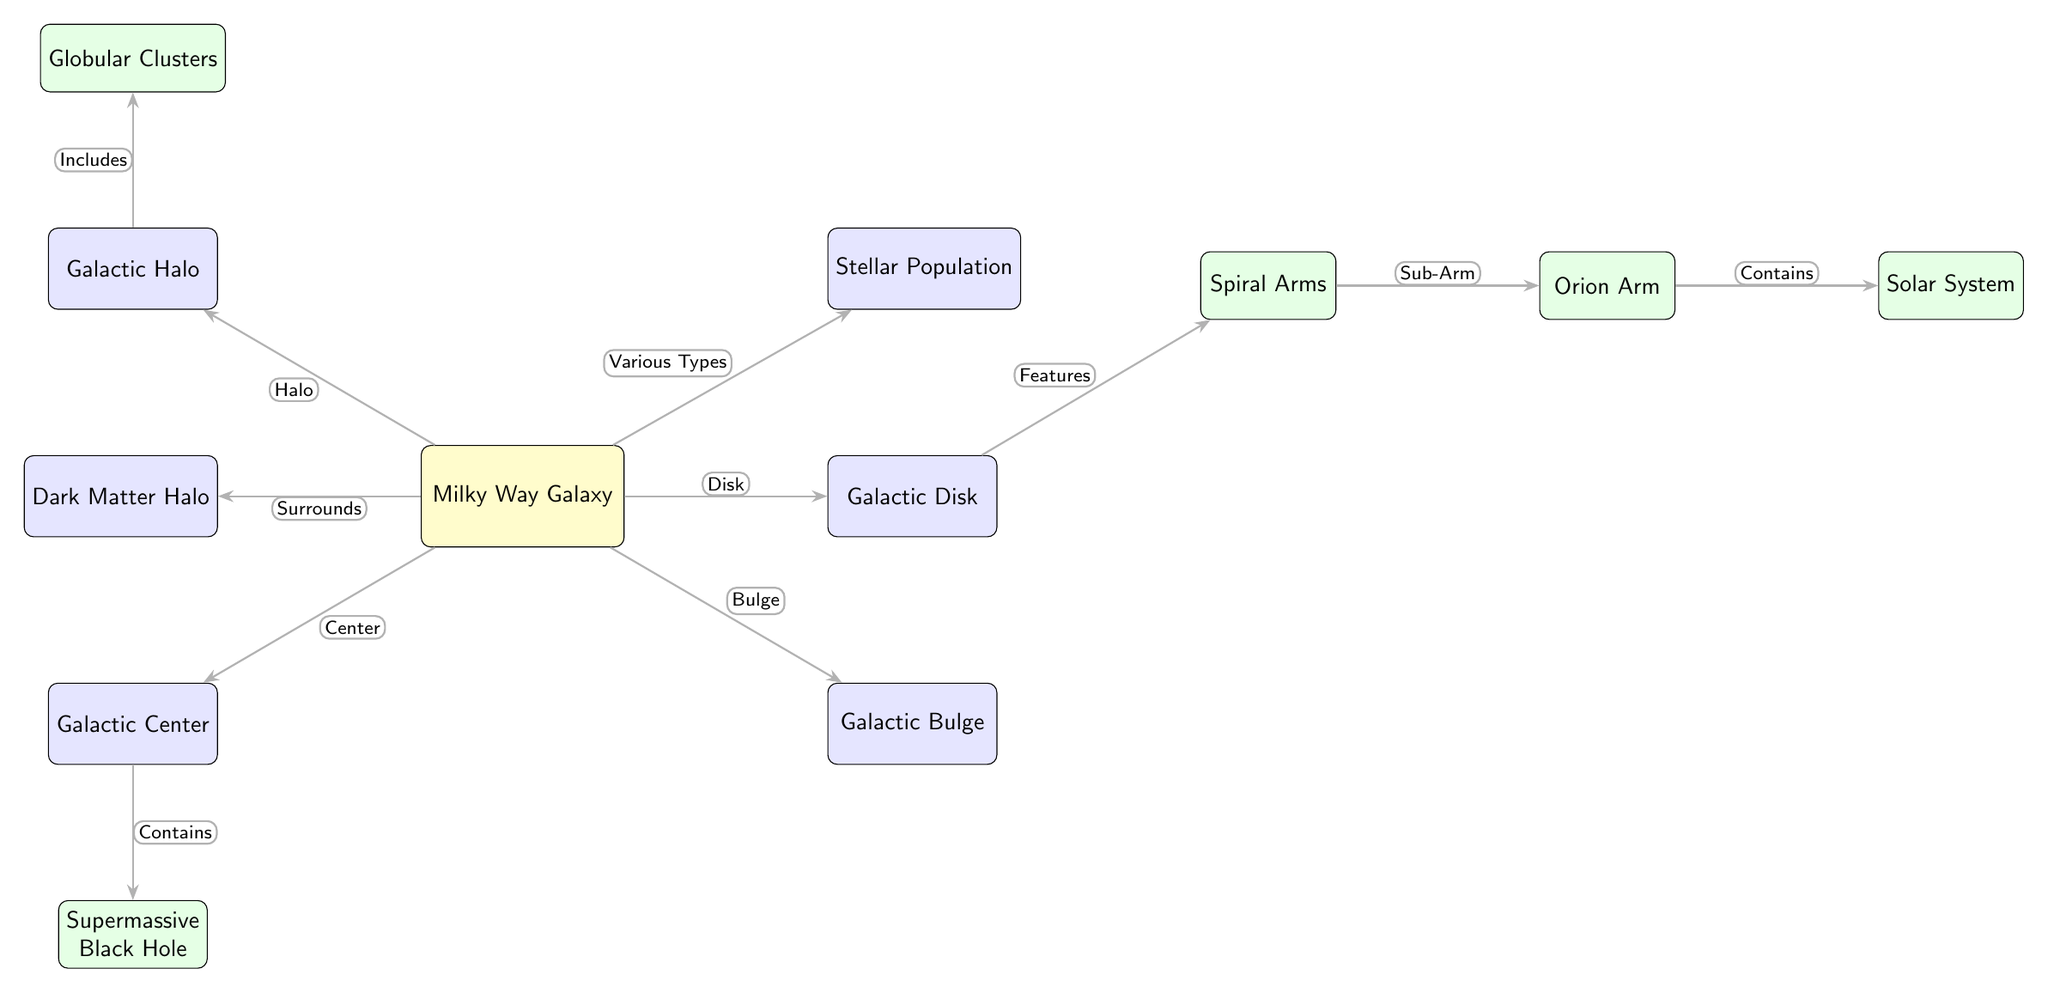What is located at the center of the Milky Way Galaxy? The diagram indicates that the Galactic Center is the central point of the Milky Way Galaxy, directly linked to the node labeled "Milky Way Galaxy" and showing "Center" as the relationship.
Answer: Galactic Center How many major parts of the Milky Way Galaxy are indicated in the diagram? The diagram identifies three major parts of the Milky Way: Galactic Center, Galactic Bulge, and Galactic Disk, clearly connected to the main node "Milky Way Galaxy."
Answer: 3 What are the two components directly connected to the Galactic Halo? By examining the edges, we see the Galactic Halo is connected to the Milky Way under "Halo" and to Globular Clusters under "Includes."
Answer: Milky Way, Globular Clusters Which component surrounds the Milky Way Galaxy? The diagram specifies the Dark Matter Halo surrounding the Milky Way Galaxy, as indicated by the "Surrounds" relationship tagged on the edge connecting to the main node.
Answer: Dark Matter Halo What does the Orion Arm contain? According to the diagram, the Orion Arm is directly linked to the Solar System as a "Contains" relationship, clearly indicating its content.
Answer: Solar System What feature branches from the Galactic Disk in the diagram? The Spiral Arms are shown to branch from the Galactic Disk with an edge labeled "Features," indicating the hierarchical relationship between the two components.
Answer: Spiral Arms Which part of the Milky Way is characterized by various types? The Stellar Population node indicates it is described as "Various Types," making it unique in its representation among the Milky Way components.
Answer: Stellar Population What is the relationship between the Galactic Center and the Supermassive Black Hole? The edge connecting these two nodes explicitly denotes the relationship "Contains," indicating that the Galactic Center houses the Supermassive Black Hole.
Answer: Contains 